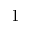<formula> <loc_0><loc_0><loc_500><loc_500>1</formula> 